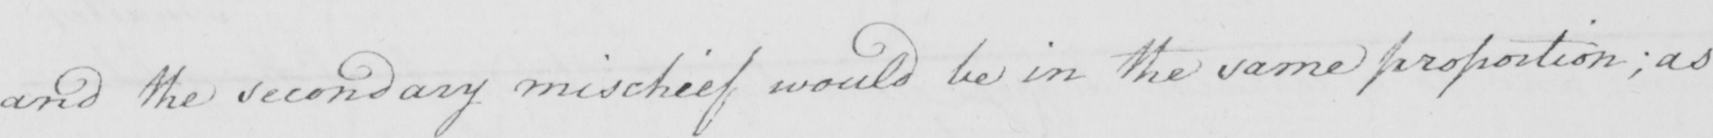What is written in this line of handwriting? and the secondary mischief would be in the same proportion ; as 